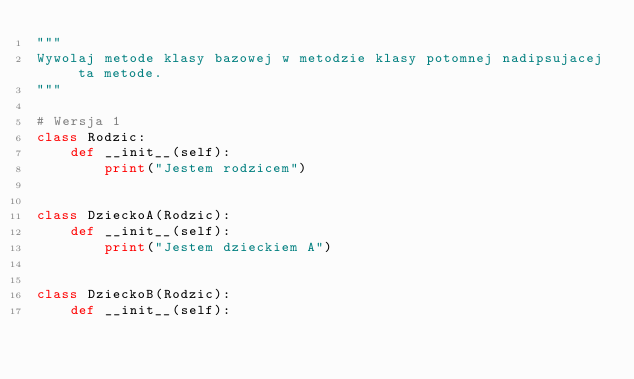Convert code to text. <code><loc_0><loc_0><loc_500><loc_500><_Python_>"""
Wywolaj metode klasy bazowej w metodzie klasy potomnej nadipsujacej ta metode.
"""

# Wersja 1
class Rodzic:
    def __init__(self):
        print("Jestem rodzicem")


class DzieckoA(Rodzic):
    def __init__(self):
        print("Jestem dzieckiem A")


class DzieckoB(Rodzic):
    def __init__(self):</code> 